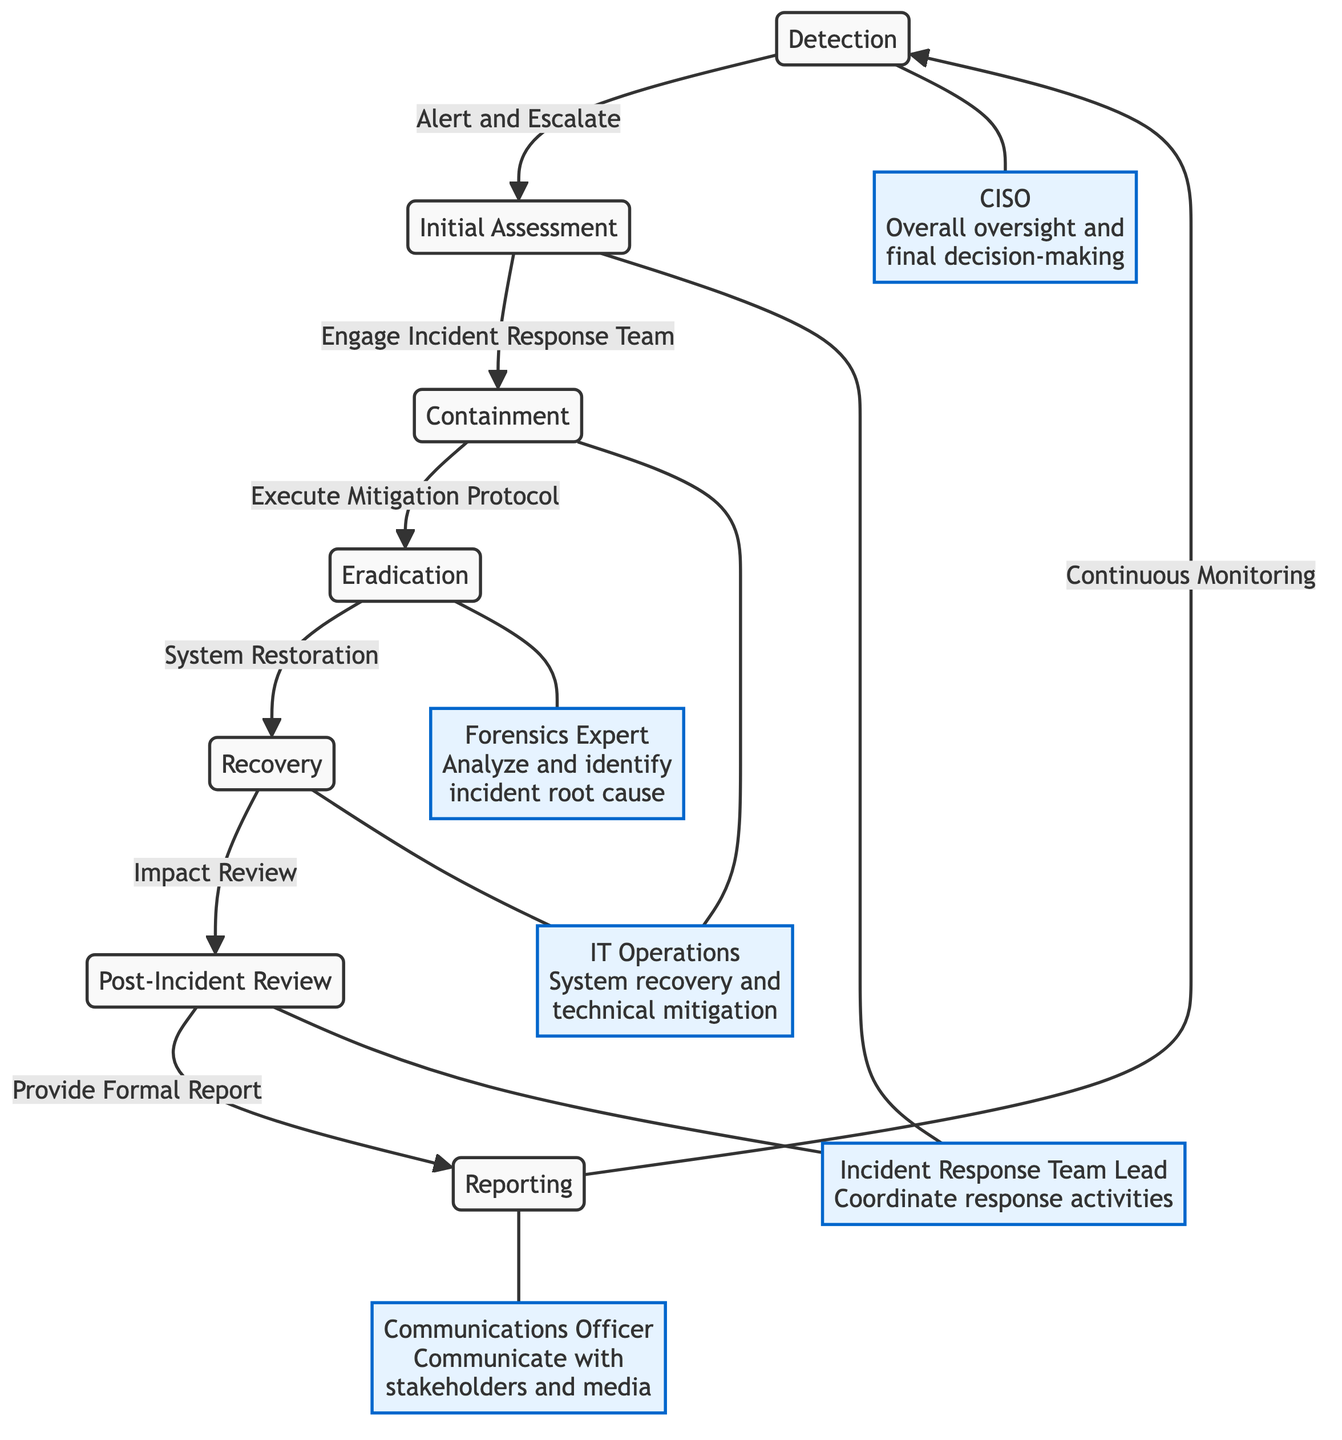What is the first step in the Cybersecurity Incident Response Process? The first step in the process is labeled "Detection." It is the initial phase where potential incidents are identified.
Answer: Detection How many roles are defined in the diagram? The diagram specifies five distinct roles that contribute to various phases of the incident response process.
Answer: Five Which role is responsible for communicating with stakeholders and media? The role responsible for this task is labeled "Communications Officer." This is indicated in the diagram at the reporting phase.
Answer: Communications Officer What follows the "Containment" step in the flow? After "Containment," the diagram shows the next step as "Eradication," indicating the sequential response actions taken post containment.
Answer: Eradication Which step includes "Impact Review"? The "Impact Review" is part of the "Recovery" phase, where the impact of the incident is assessed after system restoration. This can be traced through the flow from recovery to post-incident review.
Answer: Recovery Who has overall oversight and final decision-making? The "CISO" is identified in the diagram as having overall oversight and final decision-making authority within the incident response process.
Answer: CISO What action is taken after the "Post-Incident Review"? Following the "Post-Incident Review," the next action in the process is "Continuous Monitoring," which feeds back into the "Detection" phase.
Answer: Continuous Monitoring How are the roles connected to the "Initial Assessment" step? The "Initial Assessment" step is linked to the "Incident Response Team Lead," indicating their responsibility to engage and coordinate activities during this phase.
Answer: Incident Response Team Lead What is the main action in the "Recovery" phase? The main action in the "Recovery" phase is labeled as "System Restoration," which indicates the effort to restore affected systems after an incident.
Answer: System Restoration 